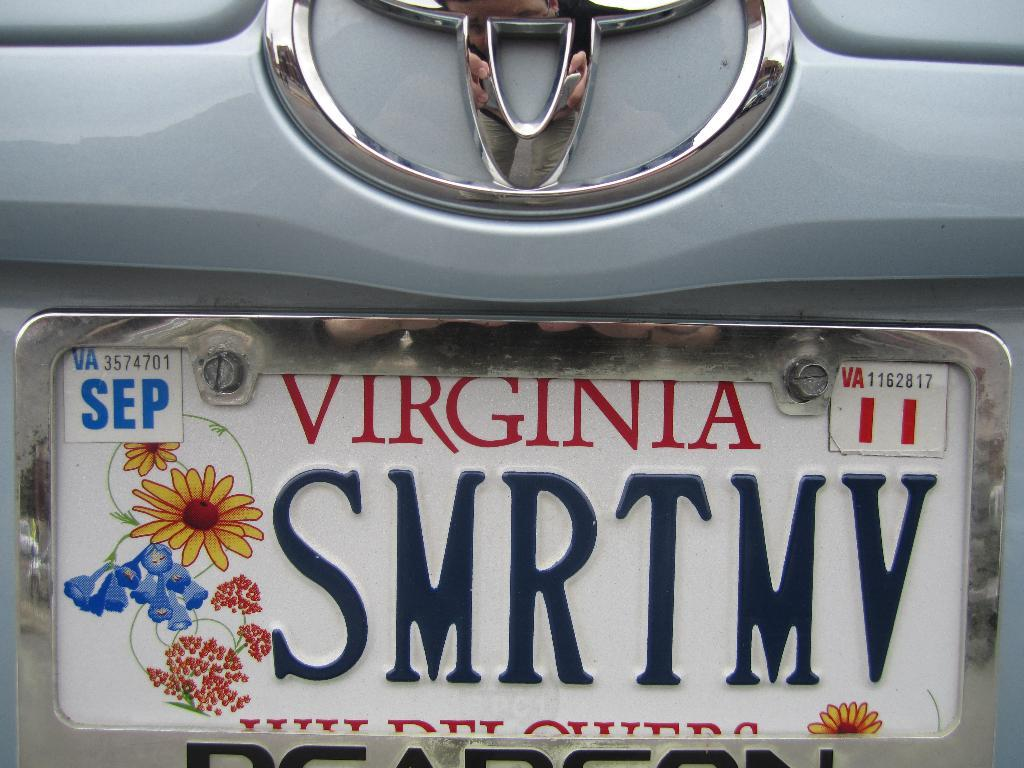Provide a one-sentence caption for the provided image. A Virginia licence plate with flowers and an expiration of September. 